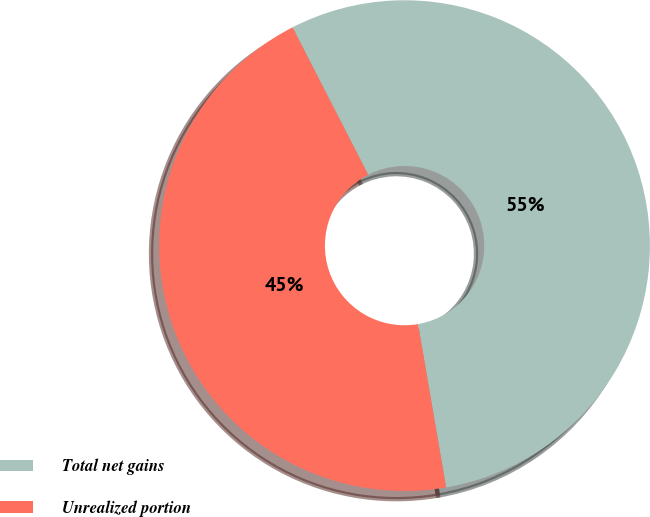Convert chart to OTSL. <chart><loc_0><loc_0><loc_500><loc_500><pie_chart><fcel>Total net gains<fcel>Unrealized portion<nl><fcel>54.84%<fcel>45.16%<nl></chart> 